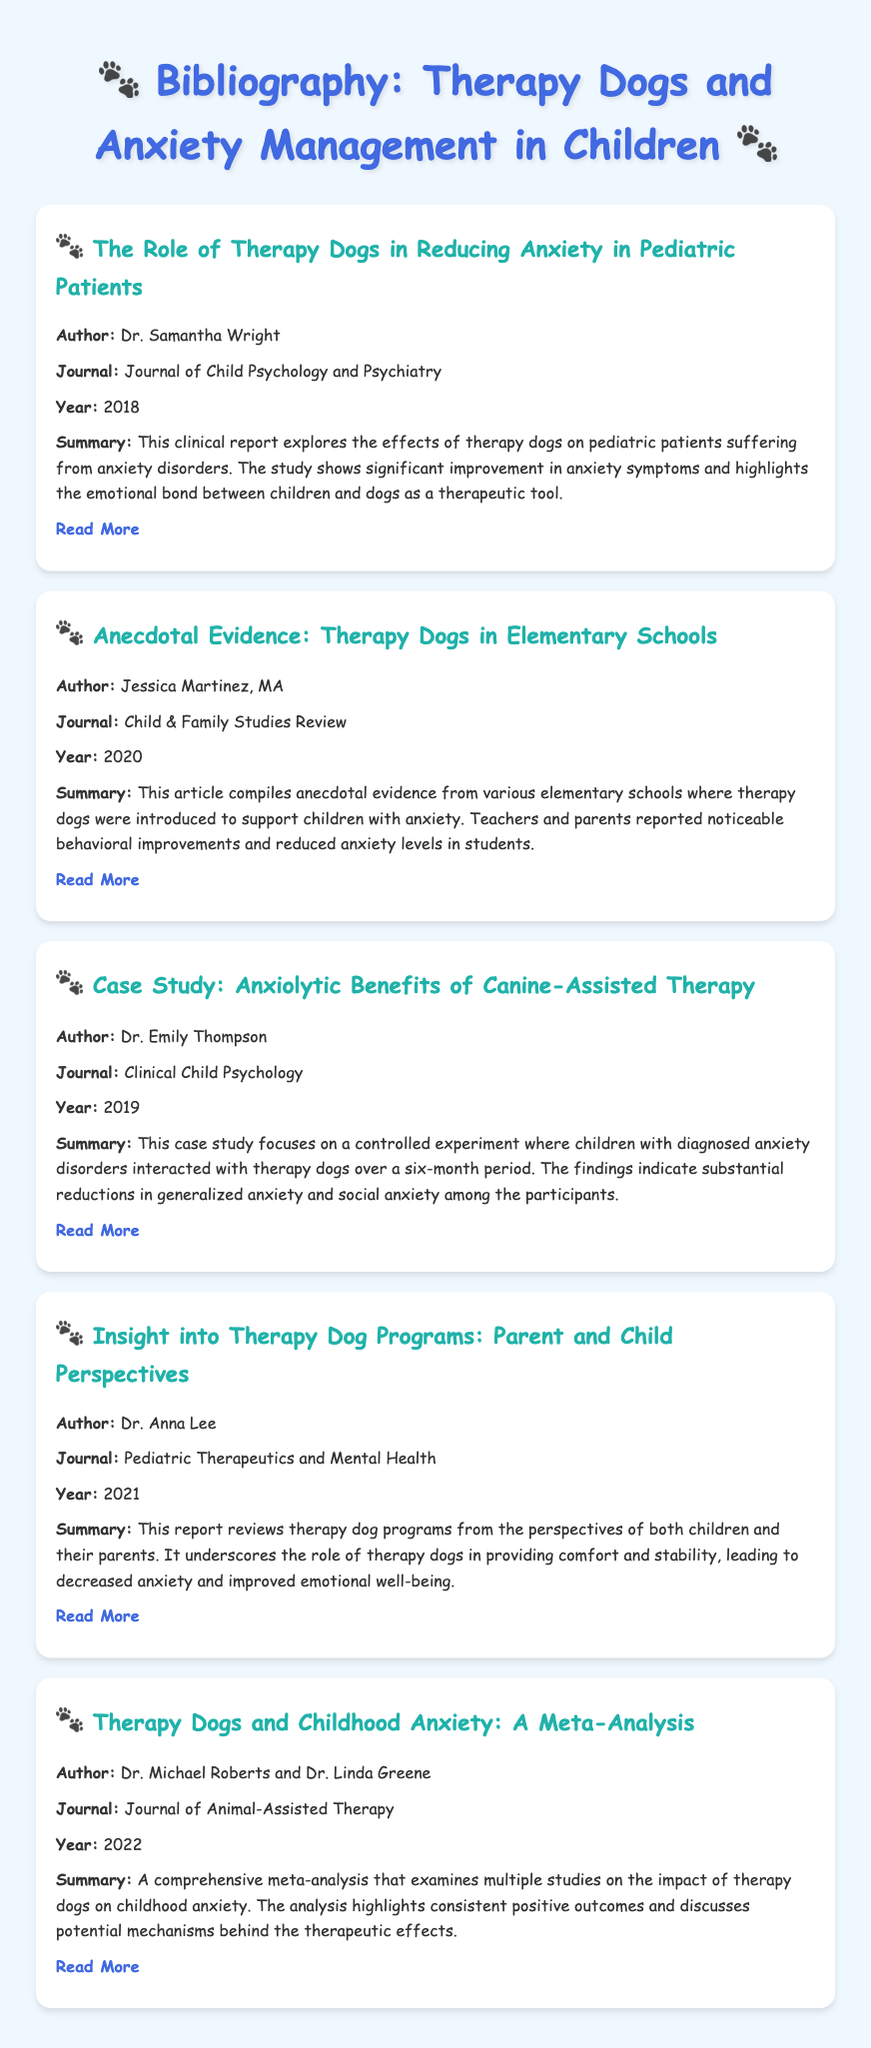What is the title of the first article? The title of the first article is presented in the document for easy access to detailed information.
Answer: The Role of Therapy Dogs in Reducing Anxiety in Pediatric Patients Who authored the case study on anxiolytic benefits? The document highlights the authors of each article, making it clear who contributed to the research.
Answer: Dr. Emily Thompson In what year was the meta-analysis published? The publication year is specified next to each entry, providing a timeline for the research.
Answer: 2022 What is the focus of Dr. Anna Lee's report? The document summarizes each entry, allowing readers to quickly understand the main themes of the research.
Answer: Parent and Child Perspectives Which journal published the article compiling anecdotal evidence? Each entry includes the journal name, helping to identify the source of the research.
Answer: Child & Family Studies Review What significant improvements were noted in the anecdotal evidence article? The summary of each article mentions key findings and observations, which reflect on the impact of therapy dogs.
Answer: Behavioral improvements and reduced anxiety levels 